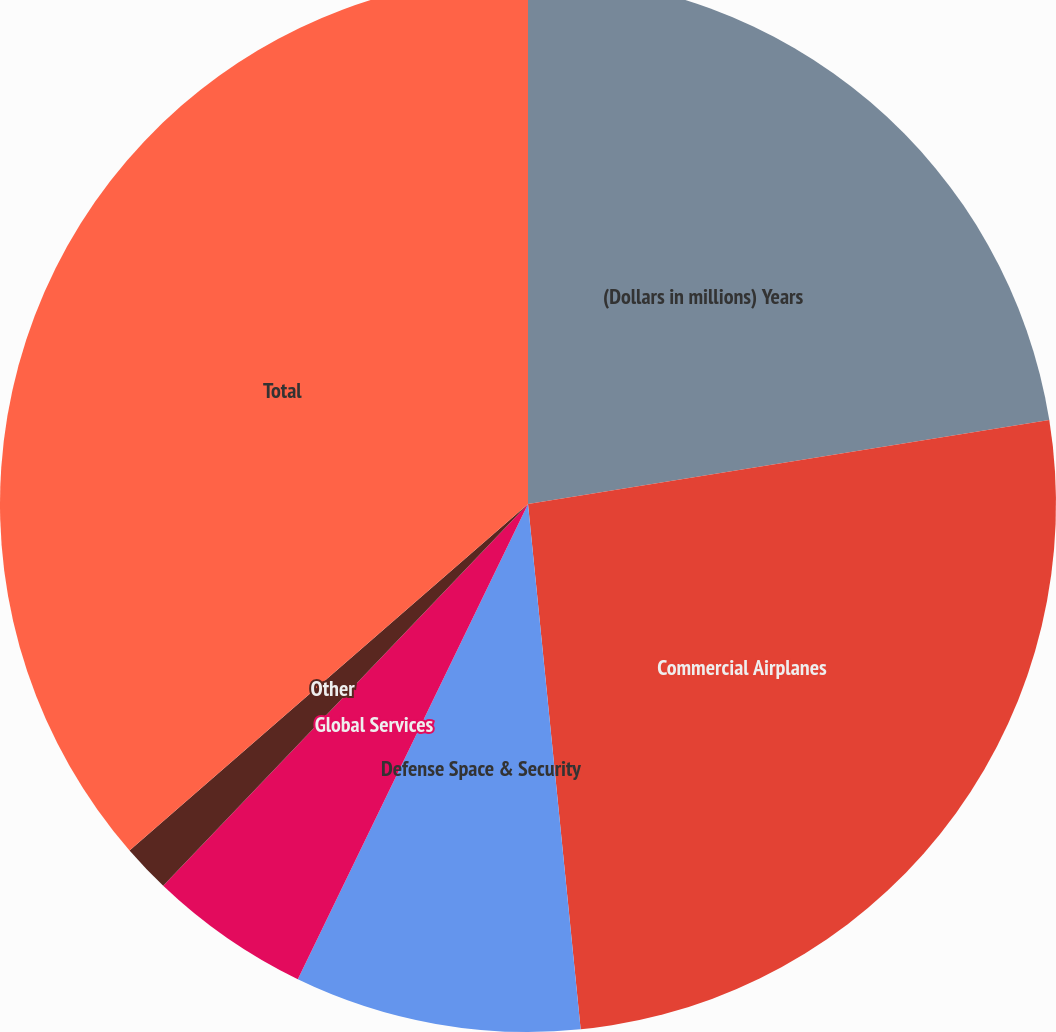Convert chart. <chart><loc_0><loc_0><loc_500><loc_500><pie_chart><fcel>(Dollars in millions) Years<fcel>Commercial Airplanes<fcel>Defense Space & Security<fcel>Global Services<fcel>Other<fcel>Total<nl><fcel>22.46%<fcel>25.95%<fcel>8.77%<fcel>4.96%<fcel>1.47%<fcel>36.39%<nl></chart> 